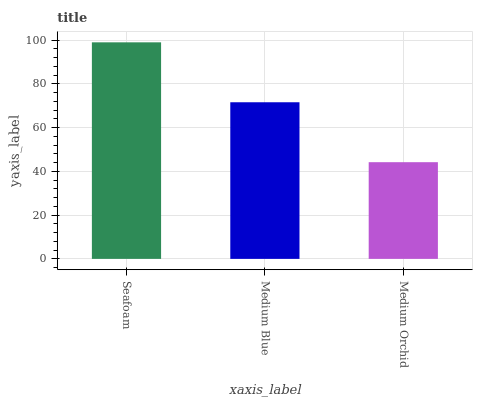Is Medium Orchid the minimum?
Answer yes or no. Yes. Is Seafoam the maximum?
Answer yes or no. Yes. Is Medium Blue the minimum?
Answer yes or no. No. Is Medium Blue the maximum?
Answer yes or no. No. Is Seafoam greater than Medium Blue?
Answer yes or no. Yes. Is Medium Blue less than Seafoam?
Answer yes or no. Yes. Is Medium Blue greater than Seafoam?
Answer yes or no. No. Is Seafoam less than Medium Blue?
Answer yes or no. No. Is Medium Blue the high median?
Answer yes or no. Yes. Is Medium Blue the low median?
Answer yes or no. Yes. Is Medium Orchid the high median?
Answer yes or no. No. Is Medium Orchid the low median?
Answer yes or no. No. 